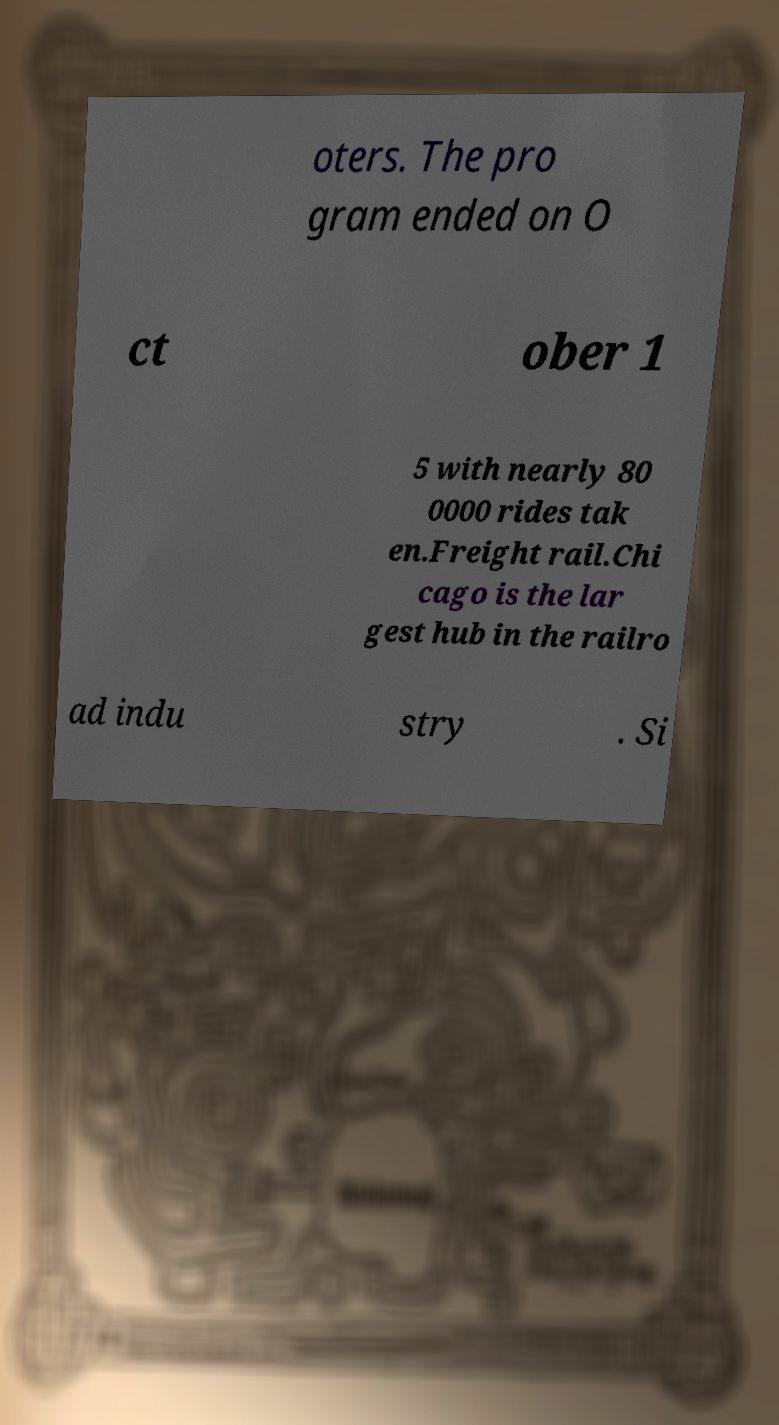For documentation purposes, I need the text within this image transcribed. Could you provide that? oters. The pro gram ended on O ct ober 1 5 with nearly 80 0000 rides tak en.Freight rail.Chi cago is the lar gest hub in the railro ad indu stry . Si 